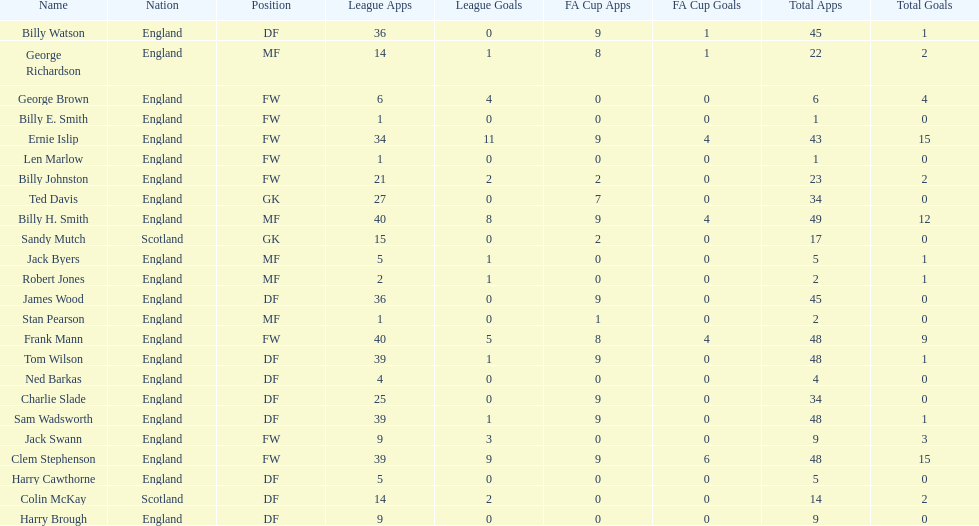Parse the full table. {'header': ['Name', 'Nation', 'Position', 'League Apps', 'League Goals', 'FA Cup Apps', 'FA Cup Goals', 'Total Apps', 'Total Goals'], 'rows': [['Billy Watson', 'England', 'DF', '36', '0', '9', '1', '45', '1'], ['George Richardson', 'England', 'MF', '14', '1', '8', '1', '22', '2'], ['George Brown', 'England', 'FW', '6', '4', '0', '0', '6', '4'], ['Billy E. Smith', 'England', 'FW', '1', '0', '0', '0', '1', '0'], ['Ernie Islip', 'England', 'FW', '34', '11', '9', '4', '43', '15'], ['Len Marlow', 'England', 'FW', '1', '0', '0', '0', '1', '0'], ['Billy Johnston', 'England', 'FW', '21', '2', '2', '0', '23', '2'], ['Ted Davis', 'England', 'GK', '27', '0', '7', '0', '34', '0'], ['Billy H. Smith', 'England', 'MF', '40', '8', '9', '4', '49', '12'], ['Sandy Mutch', 'Scotland', 'GK', '15', '0', '2', '0', '17', '0'], ['Jack Byers', 'England', 'MF', '5', '1', '0', '0', '5', '1'], ['Robert Jones', 'England', 'MF', '2', '1', '0', '0', '2', '1'], ['James Wood', 'England', 'DF', '36', '0', '9', '0', '45', '0'], ['Stan Pearson', 'England', 'MF', '1', '0', '1', '0', '2', '0'], ['Frank Mann', 'England', 'FW', '40', '5', '8', '4', '48', '9'], ['Tom Wilson', 'England', 'DF', '39', '1', '9', '0', '48', '1'], ['Ned Barkas', 'England', 'DF', '4', '0', '0', '0', '4', '0'], ['Charlie Slade', 'England', 'DF', '25', '0', '9', '0', '34', '0'], ['Sam Wadsworth', 'England', 'DF', '39', '1', '9', '0', '48', '1'], ['Jack Swann', 'England', 'FW', '9', '3', '0', '0', '9', '3'], ['Clem Stephenson', 'England', 'FW', '39', '9', '9', '6', '48', '15'], ['Harry Cawthorne', 'England', 'DF', '5', '0', '0', '0', '5', '0'], ['Colin McKay', 'Scotland', 'DF', '14', '2', '0', '0', '14', '2'], ['Harry Brough', 'England', 'DF', '9', '0', '0', '0', '9', '0']]} How many players are fws? 8. 